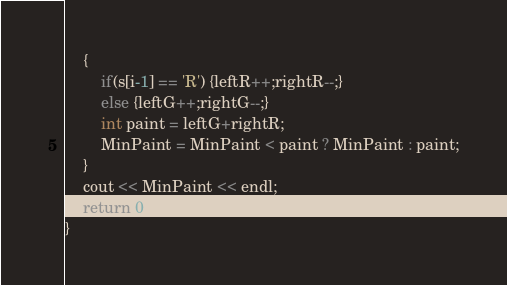<code> <loc_0><loc_0><loc_500><loc_500><_C++_>    {
        if(s[i-1] == 'R') {leftR++;rightR--;}
        else {leftG++;rightG--;}
        int paint = leftG+rightR;
        MinPaint = MinPaint < paint ? MinPaint : paint;
    }
    cout << MinPaint << endl;
    return 0;
}
</code> 